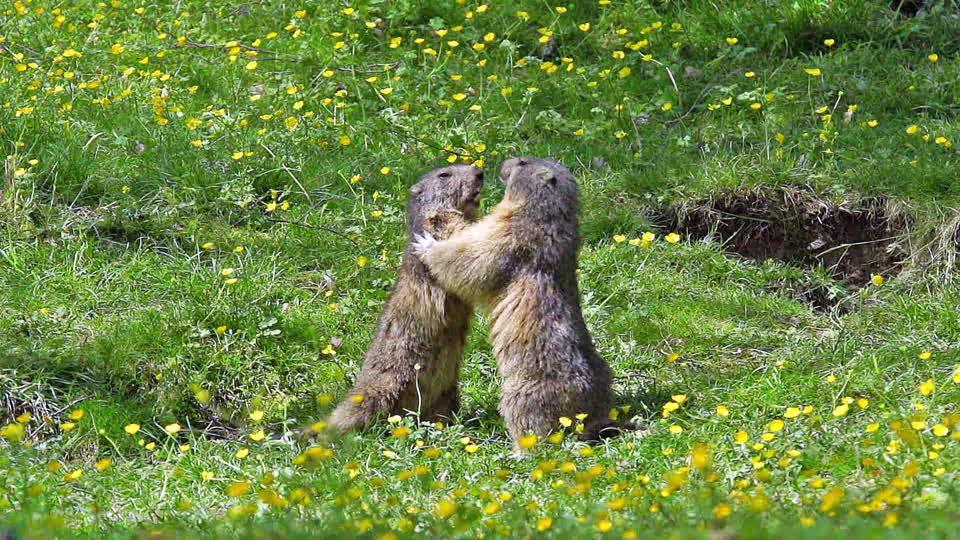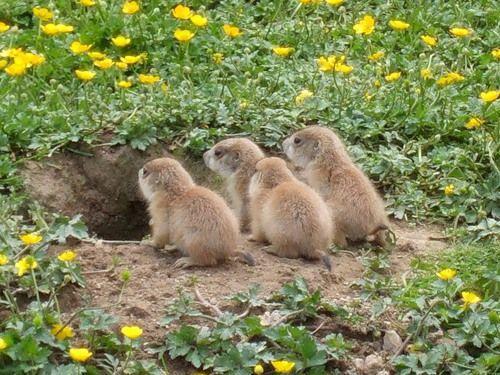The first image is the image on the left, the second image is the image on the right. For the images displayed, is the sentence "At least one image contains 3 or more animals." factually correct? Answer yes or no. Yes. The first image is the image on the left, the second image is the image on the right. For the images displayed, is the sentence "In each image, there are at least two animals." factually correct? Answer yes or no. Yes. 